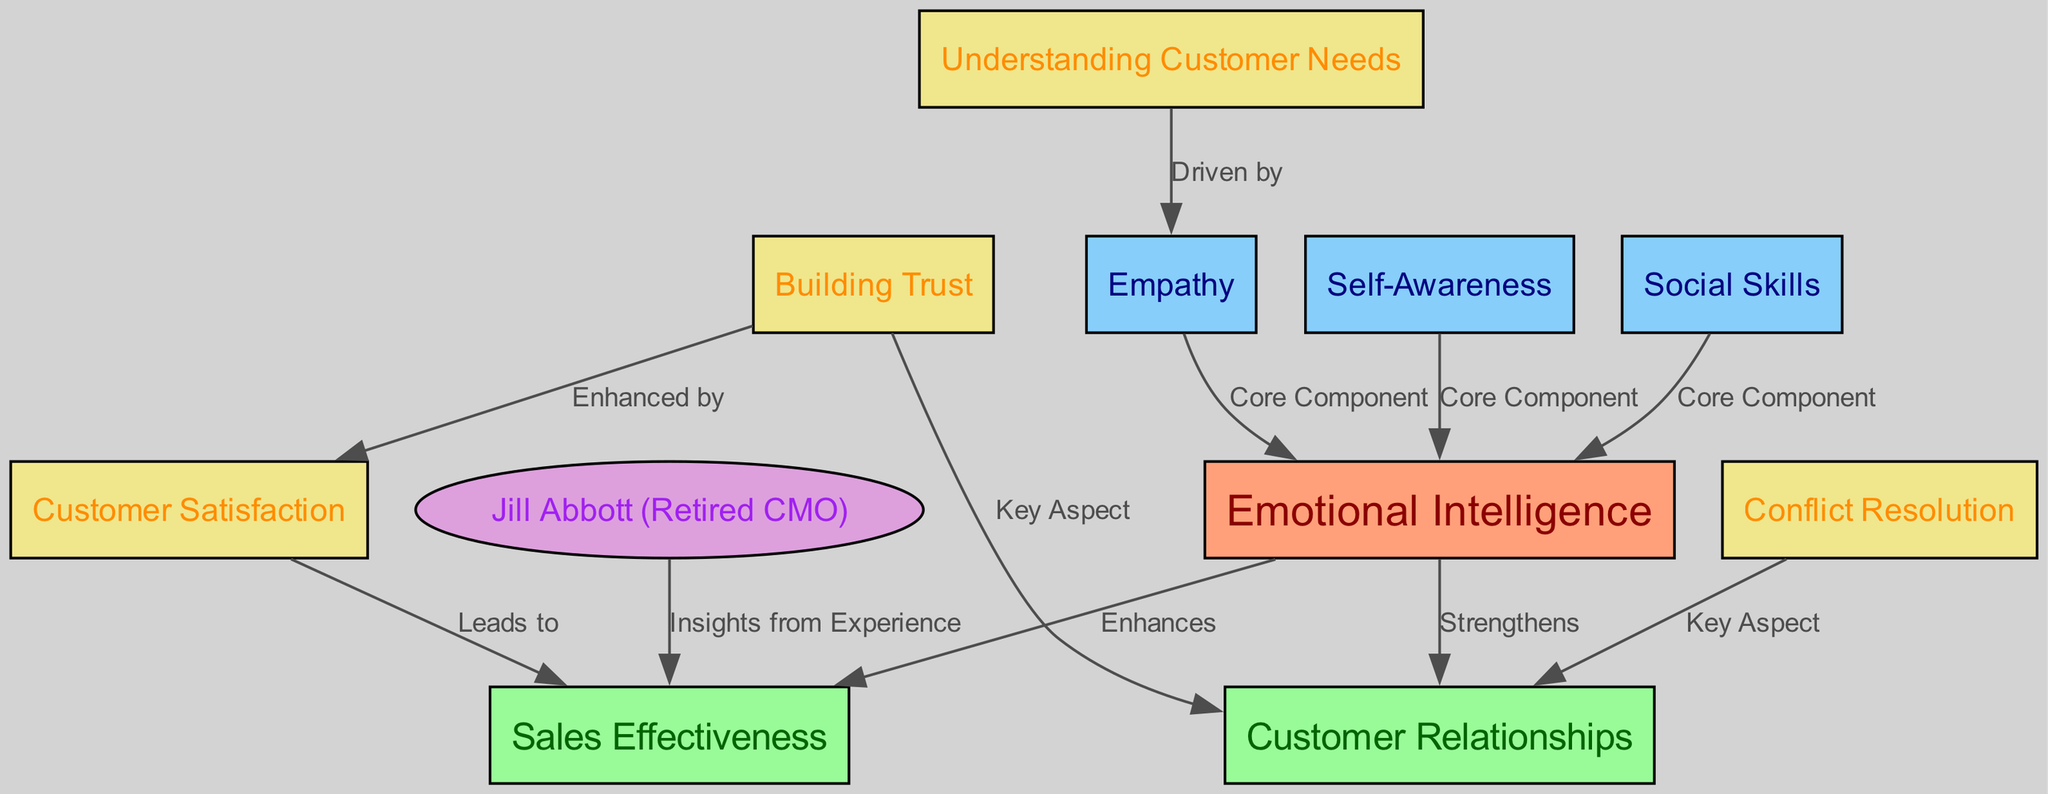What are the core components of emotional intelligence? The diagram lists three nodes as core components of emotional intelligence: self-awareness, social skills, and empathy.
Answer: self-awareness, social skills, empathy What does emotional intelligence enhance? According to the diagram, emotional intelligence enhances sales effectiveness.
Answer: sales effectiveness Who provides insights from experience regarding sales effectiveness? The diagram identifies Jill Abbott as the source of insights from experience in the context of sales effectiveness.
Answer: Jill Abbott What is a key aspect of building trust in customer relationships? The diagram indicates that building trust is a key aspect of customer relationships.
Answer: key aspect How does understanding customer needs relate to empathy? The diagram shows that understanding customer needs is driven by empathy, establishing a relationship between the two concepts.
Answer: driven by What two concepts lead to customer satisfaction? The diagram illustrates that customer satisfaction is led by sales effectiveness and is enhanced by building trust.
Answer: sales effectiveness, building trust How many total nodes are present in the diagram? By counting the nodes depicted in the diagram, we identify that there are 11 nodes.
Answer: 11 In what way does emotional intelligence strengthen customer relationships? The diagram indicates that emotional intelligence strengthens customer relationships, which emphasizes its importance in this context.
Answer: strengthens What does conflict resolution contribute to in customer relationships? The diagram lists conflict resolution as a key aspect that contributes to customer relationships.
Answer: key aspect 